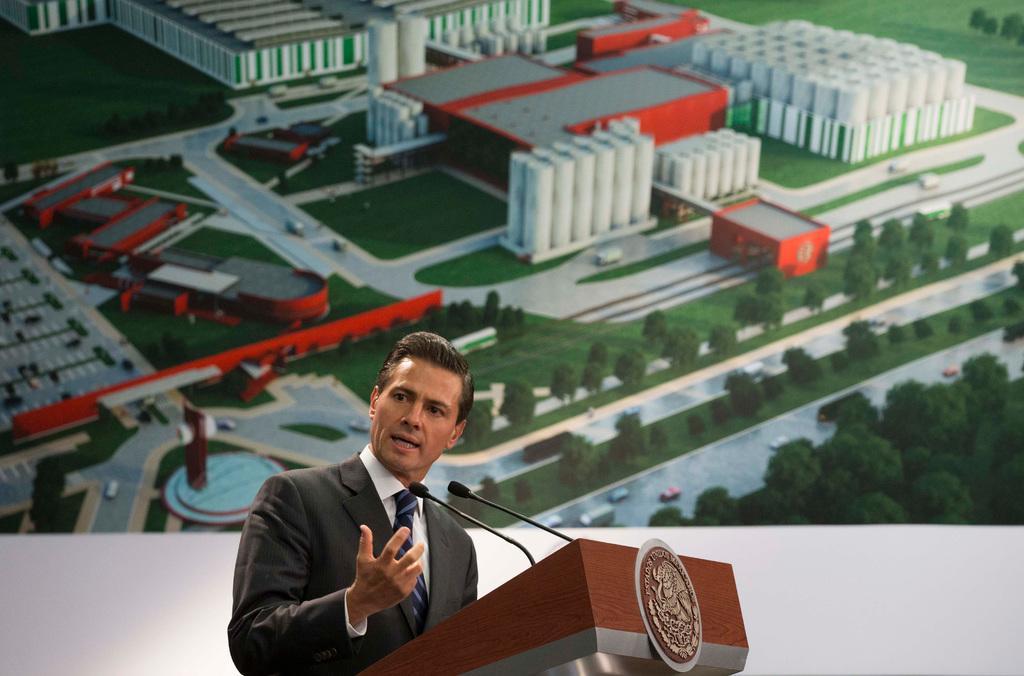In one or two sentences, can you explain what this image depicts? In the background we can see a board. In this picture we can see a man wearing a shirt, tie, blazer and standing. He is talking. We can see a podium and microphones. 